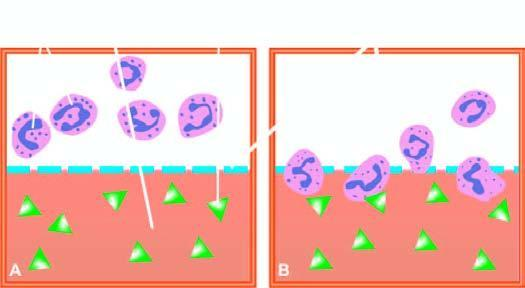what does lower half of chamber show?
Answer the question using a single word or phrase. Migration neutrophils towards chemotactic agent 